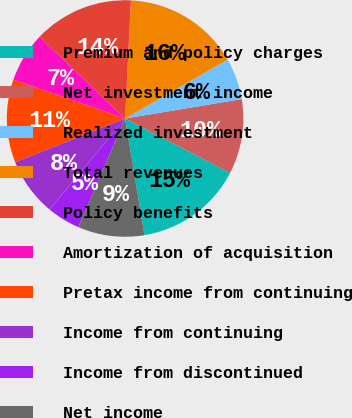Convert chart. <chart><loc_0><loc_0><loc_500><loc_500><pie_chart><fcel>Premium and policy charges<fcel>Net investment income<fcel>Realized investment<fcel>Total revenues<fcel>Policy benefits<fcel>Amortization of acquisition<fcel>Pretax income from continuing<fcel>Income from continuing<fcel>Income from discontinued<fcel>Net income<nl><fcel>14.77%<fcel>10.23%<fcel>5.68%<fcel>15.91%<fcel>13.64%<fcel>6.82%<fcel>11.36%<fcel>7.95%<fcel>4.55%<fcel>9.09%<nl></chart> 